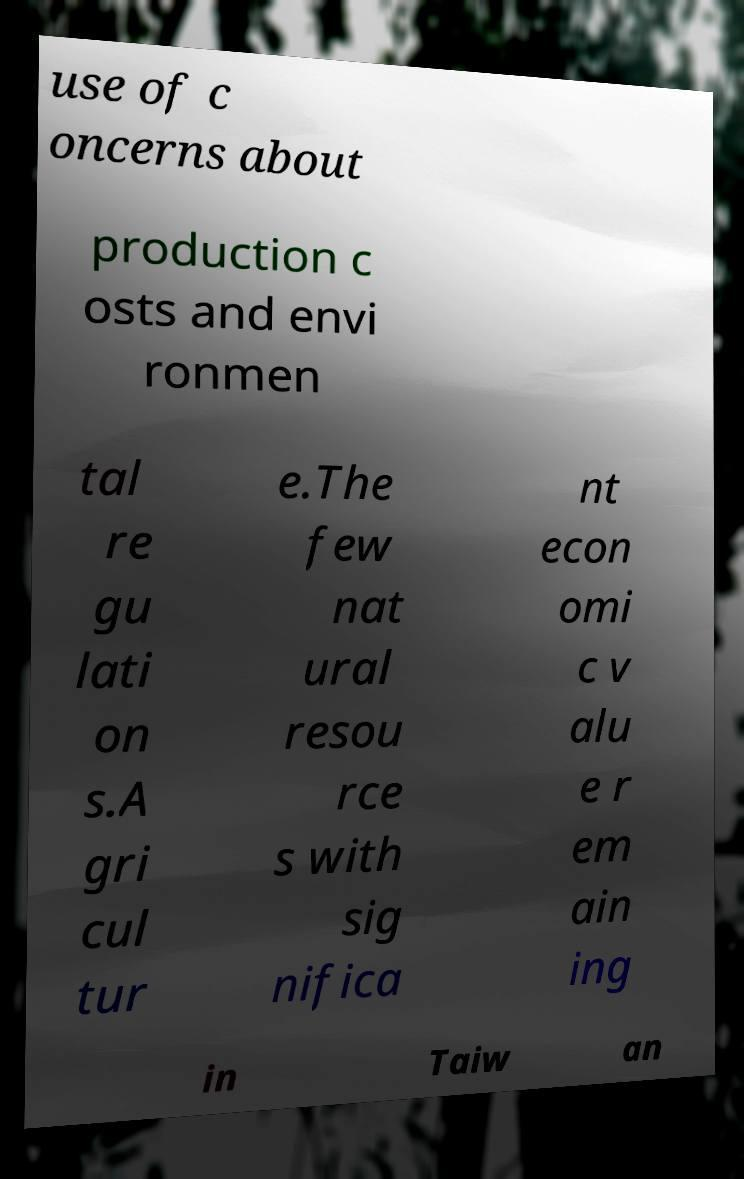For documentation purposes, I need the text within this image transcribed. Could you provide that? use of c oncerns about production c osts and envi ronmen tal re gu lati on s.A gri cul tur e.The few nat ural resou rce s with sig nifica nt econ omi c v alu e r em ain ing in Taiw an 